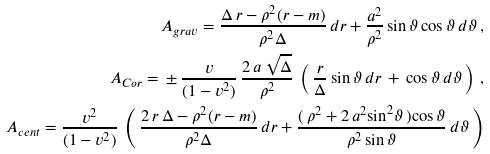<formula> <loc_0><loc_0><loc_500><loc_500>A _ { g r a v } = \frac { \Delta \, r - \rho ^ { 2 } ( r - m ) } { \rho ^ { 2 } \Delta } \, d r + \frac { a ^ { 2 } } { \rho ^ { 2 } } \, { \sin } \, \vartheta \, { \cos } \, \vartheta \, d \vartheta \, , \\ A _ { C o r } = \, \pm \, \frac { v } { ( 1 - v ^ { 2 } ) } \, \frac { 2 \, a \, \sqrt { \Delta } } { \rho ^ { 2 } } \, \left ( \, \frac { r } { \Delta } \, { \sin } \, \vartheta \, d r \, + \, { \cos } \, \vartheta \, d \vartheta \, \right ) \, , \\ A _ { c e n t } = \frac { v ^ { 2 } } { ( 1 - v ^ { 2 } ) } \, \left ( \, \frac { 2 \, r \, \Delta - \rho ^ { 2 } ( r - m ) } { \rho ^ { 2 } \Delta } \, d r + \frac { ( \, \rho ^ { 2 } + 2 \, a ^ { 2 } { \sin } ^ { 2 } \vartheta \, ) { \cos } \, \vartheta } { \rho ^ { 2 } \, { \sin } \, \vartheta } \, d \vartheta \, \right )</formula> 